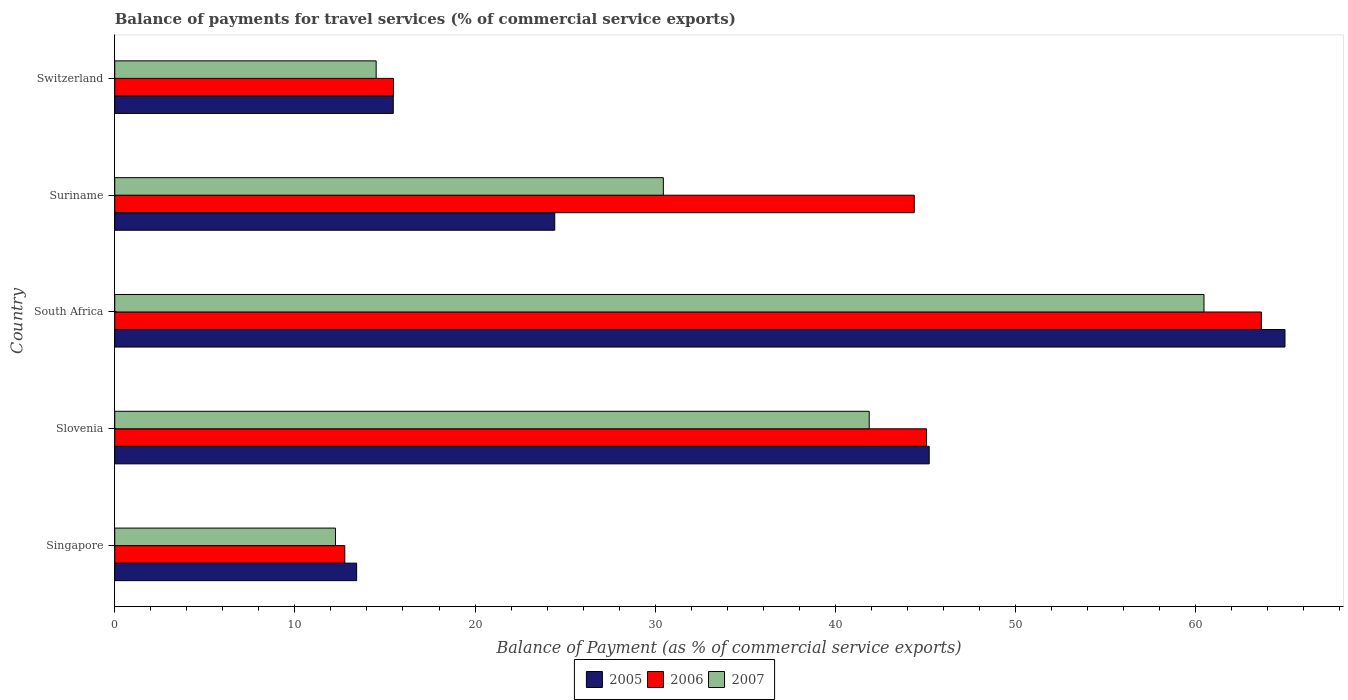How many different coloured bars are there?
Your answer should be compact. 3. What is the label of the 4th group of bars from the top?
Offer a terse response. Slovenia. What is the balance of payments for travel services in 2007 in Slovenia?
Your answer should be very brief. 41.88. Across all countries, what is the maximum balance of payments for travel services in 2005?
Provide a short and direct response. 64.96. Across all countries, what is the minimum balance of payments for travel services in 2006?
Offer a terse response. 12.77. In which country was the balance of payments for travel services in 2007 maximum?
Offer a very short reply. South Africa. In which country was the balance of payments for travel services in 2007 minimum?
Your answer should be compact. Singapore. What is the total balance of payments for travel services in 2007 in the graph?
Your response must be concise. 159.56. What is the difference between the balance of payments for travel services in 2007 in Singapore and that in South Africa?
Your answer should be very brief. -48.21. What is the difference between the balance of payments for travel services in 2007 in South Africa and the balance of payments for travel services in 2005 in Singapore?
Your answer should be compact. 47.04. What is the average balance of payments for travel services in 2005 per country?
Ensure brevity in your answer.  32.7. What is the difference between the balance of payments for travel services in 2006 and balance of payments for travel services in 2007 in Singapore?
Keep it short and to the point. 0.52. In how many countries, is the balance of payments for travel services in 2006 greater than 42 %?
Offer a terse response. 3. What is the ratio of the balance of payments for travel services in 2006 in South Africa to that in Suriname?
Make the answer very short. 1.43. Is the difference between the balance of payments for travel services in 2006 in Singapore and Suriname greater than the difference between the balance of payments for travel services in 2007 in Singapore and Suriname?
Your answer should be compact. No. What is the difference between the highest and the second highest balance of payments for travel services in 2005?
Offer a terse response. 19.75. What is the difference between the highest and the lowest balance of payments for travel services in 2006?
Your response must be concise. 50.88. In how many countries, is the balance of payments for travel services in 2007 greater than the average balance of payments for travel services in 2007 taken over all countries?
Your answer should be very brief. 2. Are the values on the major ticks of X-axis written in scientific E-notation?
Keep it short and to the point. No. Does the graph contain grids?
Your answer should be very brief. No. Where does the legend appear in the graph?
Ensure brevity in your answer.  Bottom center. How many legend labels are there?
Give a very brief answer. 3. How are the legend labels stacked?
Provide a short and direct response. Horizontal. What is the title of the graph?
Make the answer very short. Balance of payments for travel services (% of commercial service exports). Does "1994" appear as one of the legend labels in the graph?
Ensure brevity in your answer.  No. What is the label or title of the X-axis?
Offer a terse response. Balance of Payment (as % of commercial service exports). What is the label or title of the Y-axis?
Your answer should be compact. Country. What is the Balance of Payment (as % of commercial service exports) of 2005 in Singapore?
Offer a very short reply. 13.43. What is the Balance of Payment (as % of commercial service exports) in 2006 in Singapore?
Offer a terse response. 12.77. What is the Balance of Payment (as % of commercial service exports) in 2007 in Singapore?
Give a very brief answer. 12.25. What is the Balance of Payment (as % of commercial service exports) in 2005 in Slovenia?
Make the answer very short. 45.21. What is the Balance of Payment (as % of commercial service exports) in 2006 in Slovenia?
Give a very brief answer. 45.06. What is the Balance of Payment (as % of commercial service exports) of 2007 in Slovenia?
Your answer should be very brief. 41.88. What is the Balance of Payment (as % of commercial service exports) of 2005 in South Africa?
Provide a succinct answer. 64.96. What is the Balance of Payment (as % of commercial service exports) in 2006 in South Africa?
Offer a very short reply. 63.65. What is the Balance of Payment (as % of commercial service exports) of 2007 in South Africa?
Ensure brevity in your answer.  60.46. What is the Balance of Payment (as % of commercial service exports) in 2005 in Suriname?
Make the answer very short. 24.42. What is the Balance of Payment (as % of commercial service exports) in 2006 in Suriname?
Provide a short and direct response. 44.38. What is the Balance of Payment (as % of commercial service exports) of 2007 in Suriname?
Your response must be concise. 30.45. What is the Balance of Payment (as % of commercial service exports) of 2005 in Switzerland?
Offer a terse response. 15.46. What is the Balance of Payment (as % of commercial service exports) in 2006 in Switzerland?
Make the answer very short. 15.47. What is the Balance of Payment (as % of commercial service exports) in 2007 in Switzerland?
Provide a succinct answer. 14.51. Across all countries, what is the maximum Balance of Payment (as % of commercial service exports) in 2005?
Your answer should be compact. 64.96. Across all countries, what is the maximum Balance of Payment (as % of commercial service exports) in 2006?
Provide a succinct answer. 63.65. Across all countries, what is the maximum Balance of Payment (as % of commercial service exports) of 2007?
Make the answer very short. 60.46. Across all countries, what is the minimum Balance of Payment (as % of commercial service exports) of 2005?
Your response must be concise. 13.43. Across all countries, what is the minimum Balance of Payment (as % of commercial service exports) in 2006?
Your answer should be compact. 12.77. Across all countries, what is the minimum Balance of Payment (as % of commercial service exports) in 2007?
Make the answer very short. 12.25. What is the total Balance of Payment (as % of commercial service exports) of 2005 in the graph?
Provide a short and direct response. 163.49. What is the total Balance of Payment (as % of commercial service exports) in 2006 in the graph?
Give a very brief answer. 181.34. What is the total Balance of Payment (as % of commercial service exports) in 2007 in the graph?
Your answer should be compact. 159.56. What is the difference between the Balance of Payment (as % of commercial service exports) of 2005 in Singapore and that in Slovenia?
Keep it short and to the point. -31.79. What is the difference between the Balance of Payment (as % of commercial service exports) in 2006 in Singapore and that in Slovenia?
Your response must be concise. -32.29. What is the difference between the Balance of Payment (as % of commercial service exports) of 2007 in Singapore and that in Slovenia?
Your answer should be compact. -29.63. What is the difference between the Balance of Payment (as % of commercial service exports) in 2005 in Singapore and that in South Africa?
Offer a very short reply. -51.53. What is the difference between the Balance of Payment (as % of commercial service exports) in 2006 in Singapore and that in South Africa?
Your answer should be compact. -50.88. What is the difference between the Balance of Payment (as % of commercial service exports) of 2007 in Singapore and that in South Africa?
Make the answer very short. -48.21. What is the difference between the Balance of Payment (as % of commercial service exports) in 2005 in Singapore and that in Suriname?
Offer a very short reply. -11. What is the difference between the Balance of Payment (as % of commercial service exports) of 2006 in Singapore and that in Suriname?
Offer a very short reply. -31.61. What is the difference between the Balance of Payment (as % of commercial service exports) of 2007 in Singapore and that in Suriname?
Make the answer very short. -18.2. What is the difference between the Balance of Payment (as % of commercial service exports) in 2005 in Singapore and that in Switzerland?
Give a very brief answer. -2.03. What is the difference between the Balance of Payment (as % of commercial service exports) of 2006 in Singapore and that in Switzerland?
Your answer should be very brief. -2.7. What is the difference between the Balance of Payment (as % of commercial service exports) of 2007 in Singapore and that in Switzerland?
Provide a short and direct response. -2.26. What is the difference between the Balance of Payment (as % of commercial service exports) of 2005 in Slovenia and that in South Africa?
Provide a succinct answer. -19.75. What is the difference between the Balance of Payment (as % of commercial service exports) of 2006 in Slovenia and that in South Africa?
Ensure brevity in your answer.  -18.59. What is the difference between the Balance of Payment (as % of commercial service exports) in 2007 in Slovenia and that in South Africa?
Provide a short and direct response. -18.58. What is the difference between the Balance of Payment (as % of commercial service exports) in 2005 in Slovenia and that in Suriname?
Offer a terse response. 20.79. What is the difference between the Balance of Payment (as % of commercial service exports) of 2006 in Slovenia and that in Suriname?
Keep it short and to the point. 0.68. What is the difference between the Balance of Payment (as % of commercial service exports) of 2007 in Slovenia and that in Suriname?
Give a very brief answer. 11.43. What is the difference between the Balance of Payment (as % of commercial service exports) in 2005 in Slovenia and that in Switzerland?
Provide a short and direct response. 29.75. What is the difference between the Balance of Payment (as % of commercial service exports) in 2006 in Slovenia and that in Switzerland?
Make the answer very short. 29.59. What is the difference between the Balance of Payment (as % of commercial service exports) of 2007 in Slovenia and that in Switzerland?
Offer a very short reply. 27.37. What is the difference between the Balance of Payment (as % of commercial service exports) in 2005 in South Africa and that in Suriname?
Your response must be concise. 40.54. What is the difference between the Balance of Payment (as % of commercial service exports) in 2006 in South Africa and that in Suriname?
Ensure brevity in your answer.  19.27. What is the difference between the Balance of Payment (as % of commercial service exports) of 2007 in South Africa and that in Suriname?
Your answer should be very brief. 30.01. What is the difference between the Balance of Payment (as % of commercial service exports) in 2005 in South Africa and that in Switzerland?
Keep it short and to the point. 49.5. What is the difference between the Balance of Payment (as % of commercial service exports) of 2006 in South Africa and that in Switzerland?
Make the answer very short. 48.18. What is the difference between the Balance of Payment (as % of commercial service exports) of 2007 in South Africa and that in Switzerland?
Your answer should be compact. 45.95. What is the difference between the Balance of Payment (as % of commercial service exports) of 2005 in Suriname and that in Switzerland?
Your answer should be very brief. 8.96. What is the difference between the Balance of Payment (as % of commercial service exports) in 2006 in Suriname and that in Switzerland?
Offer a very short reply. 28.91. What is the difference between the Balance of Payment (as % of commercial service exports) of 2007 in Suriname and that in Switzerland?
Provide a short and direct response. 15.94. What is the difference between the Balance of Payment (as % of commercial service exports) in 2005 in Singapore and the Balance of Payment (as % of commercial service exports) in 2006 in Slovenia?
Offer a very short reply. -31.64. What is the difference between the Balance of Payment (as % of commercial service exports) of 2005 in Singapore and the Balance of Payment (as % of commercial service exports) of 2007 in Slovenia?
Provide a succinct answer. -28.45. What is the difference between the Balance of Payment (as % of commercial service exports) in 2006 in Singapore and the Balance of Payment (as % of commercial service exports) in 2007 in Slovenia?
Your answer should be very brief. -29.11. What is the difference between the Balance of Payment (as % of commercial service exports) in 2005 in Singapore and the Balance of Payment (as % of commercial service exports) in 2006 in South Africa?
Provide a succinct answer. -50.22. What is the difference between the Balance of Payment (as % of commercial service exports) in 2005 in Singapore and the Balance of Payment (as % of commercial service exports) in 2007 in South Africa?
Your answer should be very brief. -47.04. What is the difference between the Balance of Payment (as % of commercial service exports) in 2006 in Singapore and the Balance of Payment (as % of commercial service exports) in 2007 in South Africa?
Ensure brevity in your answer.  -47.7. What is the difference between the Balance of Payment (as % of commercial service exports) of 2005 in Singapore and the Balance of Payment (as % of commercial service exports) of 2006 in Suriname?
Offer a terse response. -30.95. What is the difference between the Balance of Payment (as % of commercial service exports) in 2005 in Singapore and the Balance of Payment (as % of commercial service exports) in 2007 in Suriname?
Provide a short and direct response. -17.03. What is the difference between the Balance of Payment (as % of commercial service exports) of 2006 in Singapore and the Balance of Payment (as % of commercial service exports) of 2007 in Suriname?
Give a very brief answer. -17.68. What is the difference between the Balance of Payment (as % of commercial service exports) of 2005 in Singapore and the Balance of Payment (as % of commercial service exports) of 2006 in Switzerland?
Ensure brevity in your answer.  -2.04. What is the difference between the Balance of Payment (as % of commercial service exports) of 2005 in Singapore and the Balance of Payment (as % of commercial service exports) of 2007 in Switzerland?
Provide a succinct answer. -1.08. What is the difference between the Balance of Payment (as % of commercial service exports) of 2006 in Singapore and the Balance of Payment (as % of commercial service exports) of 2007 in Switzerland?
Your answer should be very brief. -1.74. What is the difference between the Balance of Payment (as % of commercial service exports) of 2005 in Slovenia and the Balance of Payment (as % of commercial service exports) of 2006 in South Africa?
Your answer should be very brief. -18.44. What is the difference between the Balance of Payment (as % of commercial service exports) in 2005 in Slovenia and the Balance of Payment (as % of commercial service exports) in 2007 in South Africa?
Your answer should be compact. -15.25. What is the difference between the Balance of Payment (as % of commercial service exports) of 2006 in Slovenia and the Balance of Payment (as % of commercial service exports) of 2007 in South Africa?
Offer a terse response. -15.4. What is the difference between the Balance of Payment (as % of commercial service exports) of 2005 in Slovenia and the Balance of Payment (as % of commercial service exports) of 2006 in Suriname?
Give a very brief answer. 0.83. What is the difference between the Balance of Payment (as % of commercial service exports) in 2005 in Slovenia and the Balance of Payment (as % of commercial service exports) in 2007 in Suriname?
Provide a short and direct response. 14.76. What is the difference between the Balance of Payment (as % of commercial service exports) of 2006 in Slovenia and the Balance of Payment (as % of commercial service exports) of 2007 in Suriname?
Offer a terse response. 14.61. What is the difference between the Balance of Payment (as % of commercial service exports) in 2005 in Slovenia and the Balance of Payment (as % of commercial service exports) in 2006 in Switzerland?
Make the answer very short. 29.74. What is the difference between the Balance of Payment (as % of commercial service exports) of 2005 in Slovenia and the Balance of Payment (as % of commercial service exports) of 2007 in Switzerland?
Offer a very short reply. 30.7. What is the difference between the Balance of Payment (as % of commercial service exports) in 2006 in Slovenia and the Balance of Payment (as % of commercial service exports) in 2007 in Switzerland?
Provide a succinct answer. 30.55. What is the difference between the Balance of Payment (as % of commercial service exports) in 2005 in South Africa and the Balance of Payment (as % of commercial service exports) in 2006 in Suriname?
Keep it short and to the point. 20.58. What is the difference between the Balance of Payment (as % of commercial service exports) of 2005 in South Africa and the Balance of Payment (as % of commercial service exports) of 2007 in Suriname?
Offer a very short reply. 34.51. What is the difference between the Balance of Payment (as % of commercial service exports) in 2006 in South Africa and the Balance of Payment (as % of commercial service exports) in 2007 in Suriname?
Keep it short and to the point. 33.2. What is the difference between the Balance of Payment (as % of commercial service exports) of 2005 in South Africa and the Balance of Payment (as % of commercial service exports) of 2006 in Switzerland?
Ensure brevity in your answer.  49.49. What is the difference between the Balance of Payment (as % of commercial service exports) of 2005 in South Africa and the Balance of Payment (as % of commercial service exports) of 2007 in Switzerland?
Your answer should be compact. 50.45. What is the difference between the Balance of Payment (as % of commercial service exports) of 2006 in South Africa and the Balance of Payment (as % of commercial service exports) of 2007 in Switzerland?
Offer a terse response. 49.14. What is the difference between the Balance of Payment (as % of commercial service exports) in 2005 in Suriname and the Balance of Payment (as % of commercial service exports) in 2006 in Switzerland?
Provide a short and direct response. 8.95. What is the difference between the Balance of Payment (as % of commercial service exports) of 2005 in Suriname and the Balance of Payment (as % of commercial service exports) of 2007 in Switzerland?
Make the answer very short. 9.91. What is the difference between the Balance of Payment (as % of commercial service exports) of 2006 in Suriname and the Balance of Payment (as % of commercial service exports) of 2007 in Switzerland?
Your answer should be very brief. 29.87. What is the average Balance of Payment (as % of commercial service exports) of 2005 per country?
Provide a short and direct response. 32.7. What is the average Balance of Payment (as % of commercial service exports) in 2006 per country?
Your response must be concise. 36.27. What is the average Balance of Payment (as % of commercial service exports) in 2007 per country?
Provide a short and direct response. 31.91. What is the difference between the Balance of Payment (as % of commercial service exports) in 2005 and Balance of Payment (as % of commercial service exports) in 2006 in Singapore?
Provide a succinct answer. 0.66. What is the difference between the Balance of Payment (as % of commercial service exports) of 2005 and Balance of Payment (as % of commercial service exports) of 2007 in Singapore?
Your response must be concise. 1.17. What is the difference between the Balance of Payment (as % of commercial service exports) of 2006 and Balance of Payment (as % of commercial service exports) of 2007 in Singapore?
Provide a succinct answer. 0.52. What is the difference between the Balance of Payment (as % of commercial service exports) of 2005 and Balance of Payment (as % of commercial service exports) of 2006 in Slovenia?
Offer a very short reply. 0.15. What is the difference between the Balance of Payment (as % of commercial service exports) in 2005 and Balance of Payment (as % of commercial service exports) in 2007 in Slovenia?
Keep it short and to the point. 3.33. What is the difference between the Balance of Payment (as % of commercial service exports) in 2006 and Balance of Payment (as % of commercial service exports) in 2007 in Slovenia?
Keep it short and to the point. 3.18. What is the difference between the Balance of Payment (as % of commercial service exports) of 2005 and Balance of Payment (as % of commercial service exports) of 2006 in South Africa?
Provide a succinct answer. 1.31. What is the difference between the Balance of Payment (as % of commercial service exports) in 2005 and Balance of Payment (as % of commercial service exports) in 2007 in South Africa?
Ensure brevity in your answer.  4.5. What is the difference between the Balance of Payment (as % of commercial service exports) in 2006 and Balance of Payment (as % of commercial service exports) in 2007 in South Africa?
Provide a short and direct response. 3.18. What is the difference between the Balance of Payment (as % of commercial service exports) in 2005 and Balance of Payment (as % of commercial service exports) in 2006 in Suriname?
Offer a terse response. -19.96. What is the difference between the Balance of Payment (as % of commercial service exports) in 2005 and Balance of Payment (as % of commercial service exports) in 2007 in Suriname?
Your response must be concise. -6.03. What is the difference between the Balance of Payment (as % of commercial service exports) of 2006 and Balance of Payment (as % of commercial service exports) of 2007 in Suriname?
Ensure brevity in your answer.  13.93. What is the difference between the Balance of Payment (as % of commercial service exports) in 2005 and Balance of Payment (as % of commercial service exports) in 2006 in Switzerland?
Make the answer very short. -0.01. What is the difference between the Balance of Payment (as % of commercial service exports) in 2005 and Balance of Payment (as % of commercial service exports) in 2007 in Switzerland?
Offer a very short reply. 0.95. What is the difference between the Balance of Payment (as % of commercial service exports) of 2006 and Balance of Payment (as % of commercial service exports) of 2007 in Switzerland?
Ensure brevity in your answer.  0.96. What is the ratio of the Balance of Payment (as % of commercial service exports) of 2005 in Singapore to that in Slovenia?
Ensure brevity in your answer.  0.3. What is the ratio of the Balance of Payment (as % of commercial service exports) in 2006 in Singapore to that in Slovenia?
Provide a short and direct response. 0.28. What is the ratio of the Balance of Payment (as % of commercial service exports) of 2007 in Singapore to that in Slovenia?
Your response must be concise. 0.29. What is the ratio of the Balance of Payment (as % of commercial service exports) of 2005 in Singapore to that in South Africa?
Your response must be concise. 0.21. What is the ratio of the Balance of Payment (as % of commercial service exports) of 2006 in Singapore to that in South Africa?
Make the answer very short. 0.2. What is the ratio of the Balance of Payment (as % of commercial service exports) in 2007 in Singapore to that in South Africa?
Your answer should be compact. 0.2. What is the ratio of the Balance of Payment (as % of commercial service exports) of 2005 in Singapore to that in Suriname?
Your answer should be very brief. 0.55. What is the ratio of the Balance of Payment (as % of commercial service exports) of 2006 in Singapore to that in Suriname?
Your answer should be compact. 0.29. What is the ratio of the Balance of Payment (as % of commercial service exports) in 2007 in Singapore to that in Suriname?
Offer a very short reply. 0.4. What is the ratio of the Balance of Payment (as % of commercial service exports) in 2005 in Singapore to that in Switzerland?
Give a very brief answer. 0.87. What is the ratio of the Balance of Payment (as % of commercial service exports) of 2006 in Singapore to that in Switzerland?
Keep it short and to the point. 0.83. What is the ratio of the Balance of Payment (as % of commercial service exports) in 2007 in Singapore to that in Switzerland?
Provide a succinct answer. 0.84. What is the ratio of the Balance of Payment (as % of commercial service exports) of 2005 in Slovenia to that in South Africa?
Provide a succinct answer. 0.7. What is the ratio of the Balance of Payment (as % of commercial service exports) of 2006 in Slovenia to that in South Africa?
Give a very brief answer. 0.71. What is the ratio of the Balance of Payment (as % of commercial service exports) in 2007 in Slovenia to that in South Africa?
Ensure brevity in your answer.  0.69. What is the ratio of the Balance of Payment (as % of commercial service exports) in 2005 in Slovenia to that in Suriname?
Ensure brevity in your answer.  1.85. What is the ratio of the Balance of Payment (as % of commercial service exports) in 2006 in Slovenia to that in Suriname?
Your response must be concise. 1.02. What is the ratio of the Balance of Payment (as % of commercial service exports) of 2007 in Slovenia to that in Suriname?
Give a very brief answer. 1.38. What is the ratio of the Balance of Payment (as % of commercial service exports) in 2005 in Slovenia to that in Switzerland?
Make the answer very short. 2.92. What is the ratio of the Balance of Payment (as % of commercial service exports) in 2006 in Slovenia to that in Switzerland?
Give a very brief answer. 2.91. What is the ratio of the Balance of Payment (as % of commercial service exports) of 2007 in Slovenia to that in Switzerland?
Your response must be concise. 2.89. What is the ratio of the Balance of Payment (as % of commercial service exports) of 2005 in South Africa to that in Suriname?
Offer a terse response. 2.66. What is the ratio of the Balance of Payment (as % of commercial service exports) in 2006 in South Africa to that in Suriname?
Offer a very short reply. 1.43. What is the ratio of the Balance of Payment (as % of commercial service exports) in 2007 in South Africa to that in Suriname?
Keep it short and to the point. 1.99. What is the ratio of the Balance of Payment (as % of commercial service exports) of 2005 in South Africa to that in Switzerland?
Offer a terse response. 4.2. What is the ratio of the Balance of Payment (as % of commercial service exports) in 2006 in South Africa to that in Switzerland?
Your answer should be very brief. 4.11. What is the ratio of the Balance of Payment (as % of commercial service exports) of 2007 in South Africa to that in Switzerland?
Your answer should be compact. 4.17. What is the ratio of the Balance of Payment (as % of commercial service exports) of 2005 in Suriname to that in Switzerland?
Provide a short and direct response. 1.58. What is the ratio of the Balance of Payment (as % of commercial service exports) of 2006 in Suriname to that in Switzerland?
Provide a short and direct response. 2.87. What is the ratio of the Balance of Payment (as % of commercial service exports) in 2007 in Suriname to that in Switzerland?
Make the answer very short. 2.1. What is the difference between the highest and the second highest Balance of Payment (as % of commercial service exports) of 2005?
Give a very brief answer. 19.75. What is the difference between the highest and the second highest Balance of Payment (as % of commercial service exports) of 2006?
Provide a short and direct response. 18.59. What is the difference between the highest and the second highest Balance of Payment (as % of commercial service exports) of 2007?
Your answer should be compact. 18.58. What is the difference between the highest and the lowest Balance of Payment (as % of commercial service exports) in 2005?
Keep it short and to the point. 51.53. What is the difference between the highest and the lowest Balance of Payment (as % of commercial service exports) of 2006?
Offer a terse response. 50.88. What is the difference between the highest and the lowest Balance of Payment (as % of commercial service exports) of 2007?
Give a very brief answer. 48.21. 